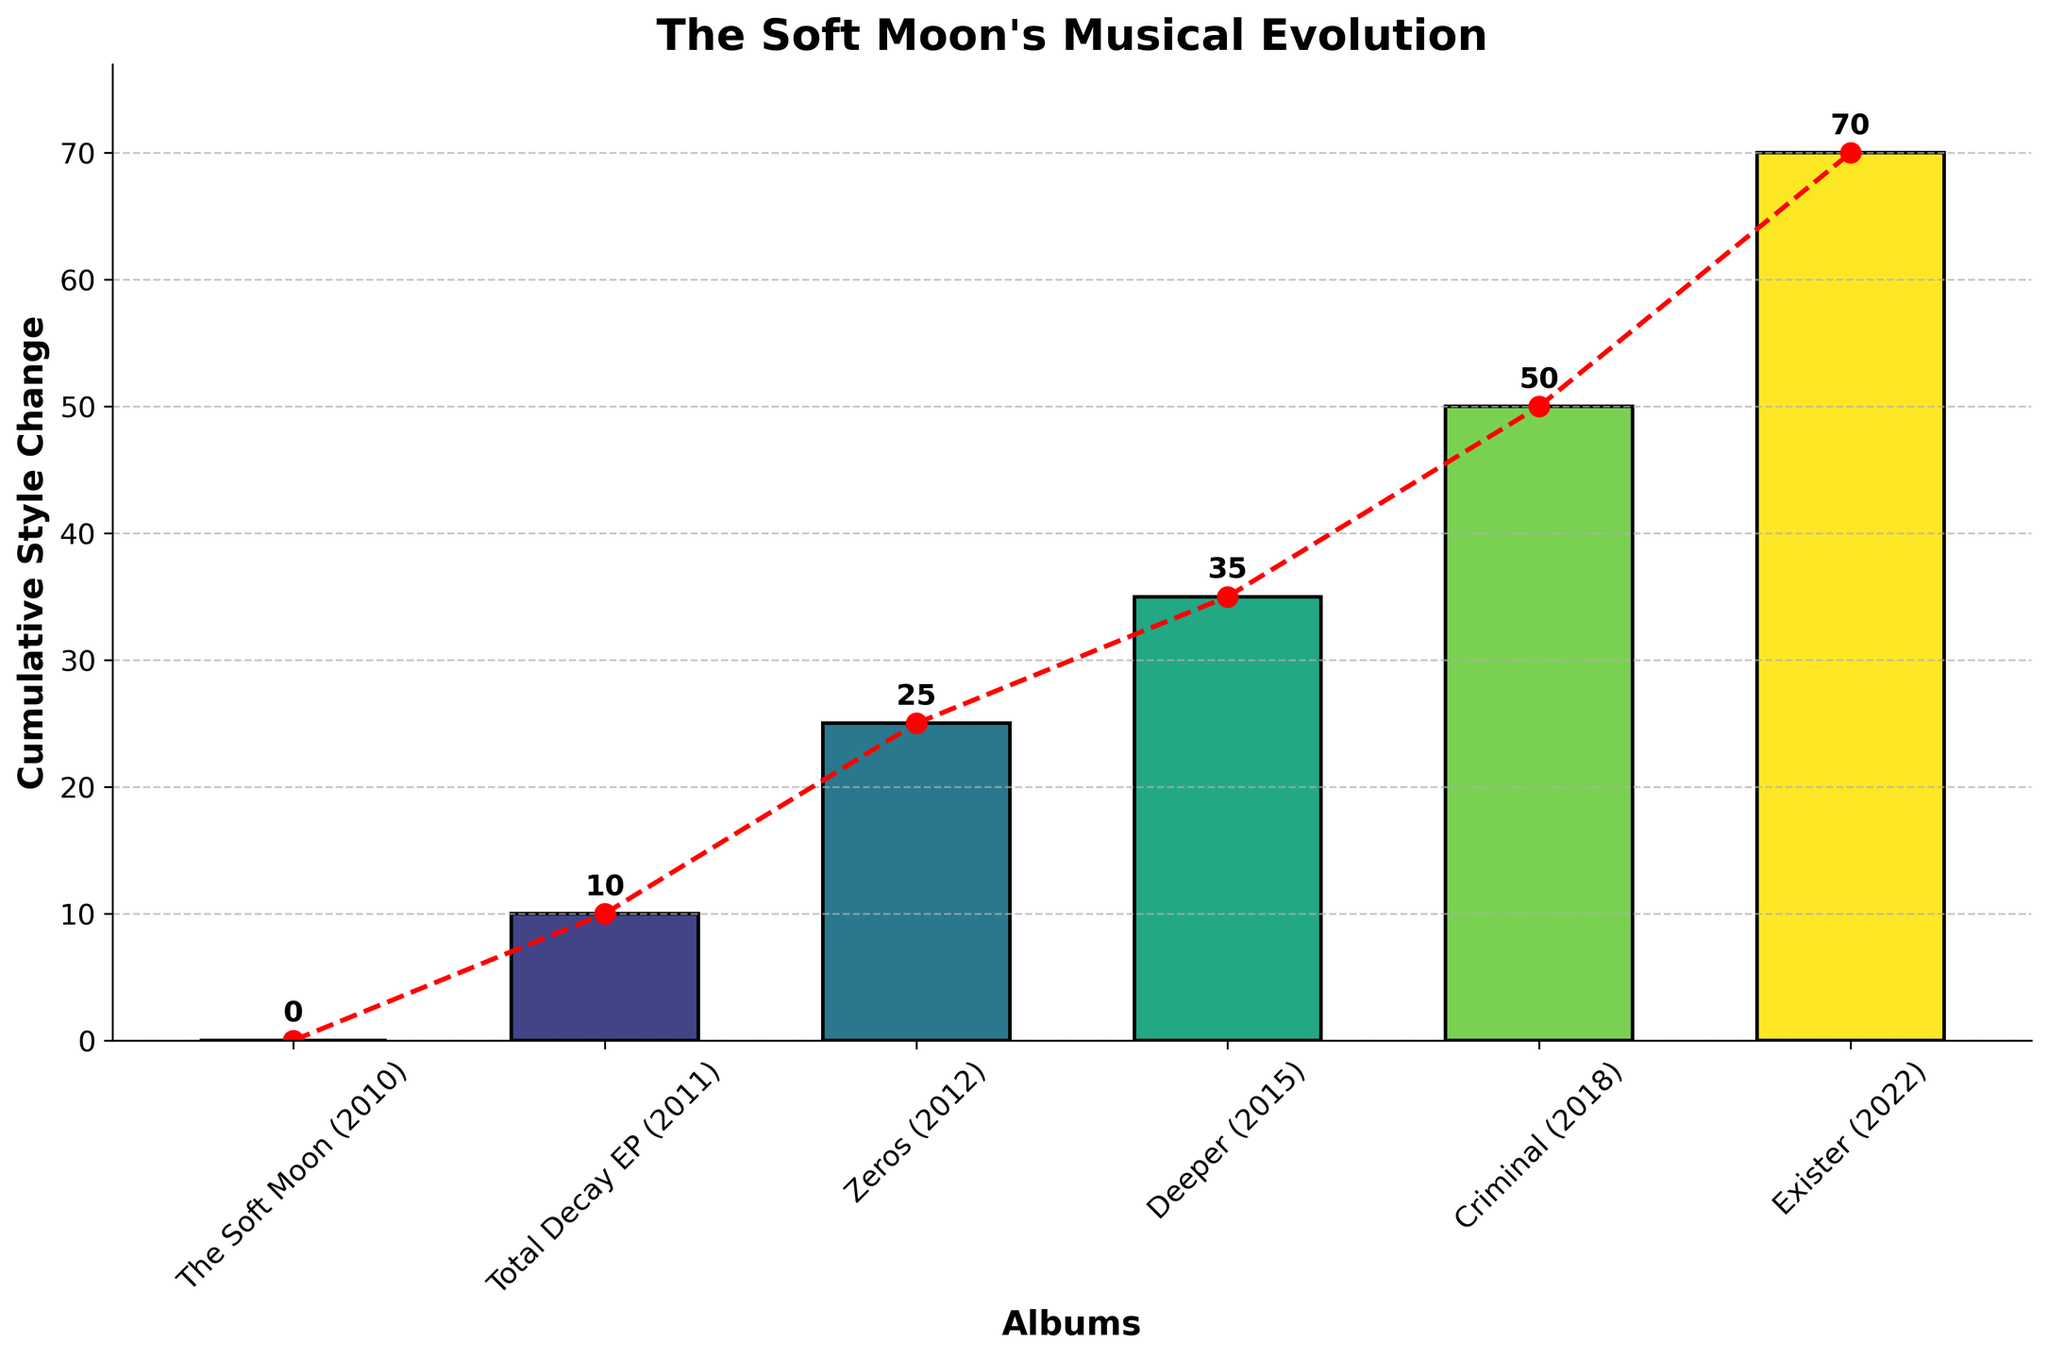What's the title of the chart? The title of the chart is typically placed at the top and is designed to summarize the content of the chart. In this case, it reads "The Soft Moon's Musical Evolution".
Answer: The Soft Moon's Musical Evolution How many albums are displayed in the chart? Count the distinct data points on the x-axis which correspond to the albums. There are six albums listed on the x-axis.
Answer: 6 What is the cumulative style change for the album 'Criminal'? Locate the bar corresponding to 'Criminal' and read the value at the top of the bar. The value at the top of 'Criminal' bar is 50.
Answer: 50 Which album shows the highest cumulative style change? Identify the tallest bar in the chart. The tallest bar corresponds to the album 'Exister'.
Answer: Exister By how much did the cumulative style change increase from 'The Soft Moon' to 'Total Decay EP'? Subtract the cumulative style change of 'The Soft Moon' from the cumulative style change of 'Total Decay EP': 10 - 0 = 10.
Answer: 10 What is the average cumulative style change across all albums? Sum up all the cumulative style changes (0 + 10 + 25 + 35 + 50 + 70 = 190) and divide by the number of albums (6): 190 / 6 = approximately 31.67.
Answer: 31.67 Is the cumulative style change from 'Zeros' to 'Exister' consistently increasing or decreasing? From 'Zeros' to 'Exister', check if each subsequent value is higher or lower. The sequence is 25, 35, 50, 70, which consistently increases.
Answer: Increasing What is the difference in cumulative style change between 'Deeper' and 'Exister'? Subtract the cumulative style change of 'Deeper' from 'Exister': 70 - 35 = 35.
Answer: 35 Which album represents the point where the cumulative style change first surpassed 30? Identify which album first has a cumulative style change greater than 30. 'Deeper' has a cumulative style change of 35, surpassing 30.
Answer: Deeper 